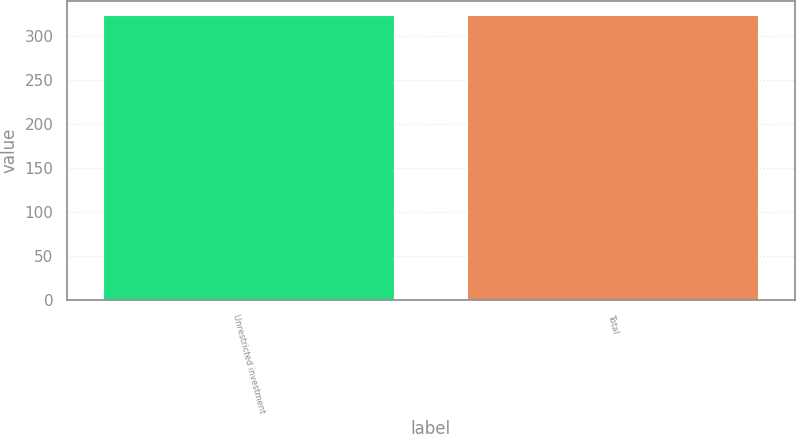Convert chart. <chart><loc_0><loc_0><loc_500><loc_500><bar_chart><fcel>Unrestricted investment<fcel>Total<nl><fcel>324<fcel>324.1<nl></chart> 